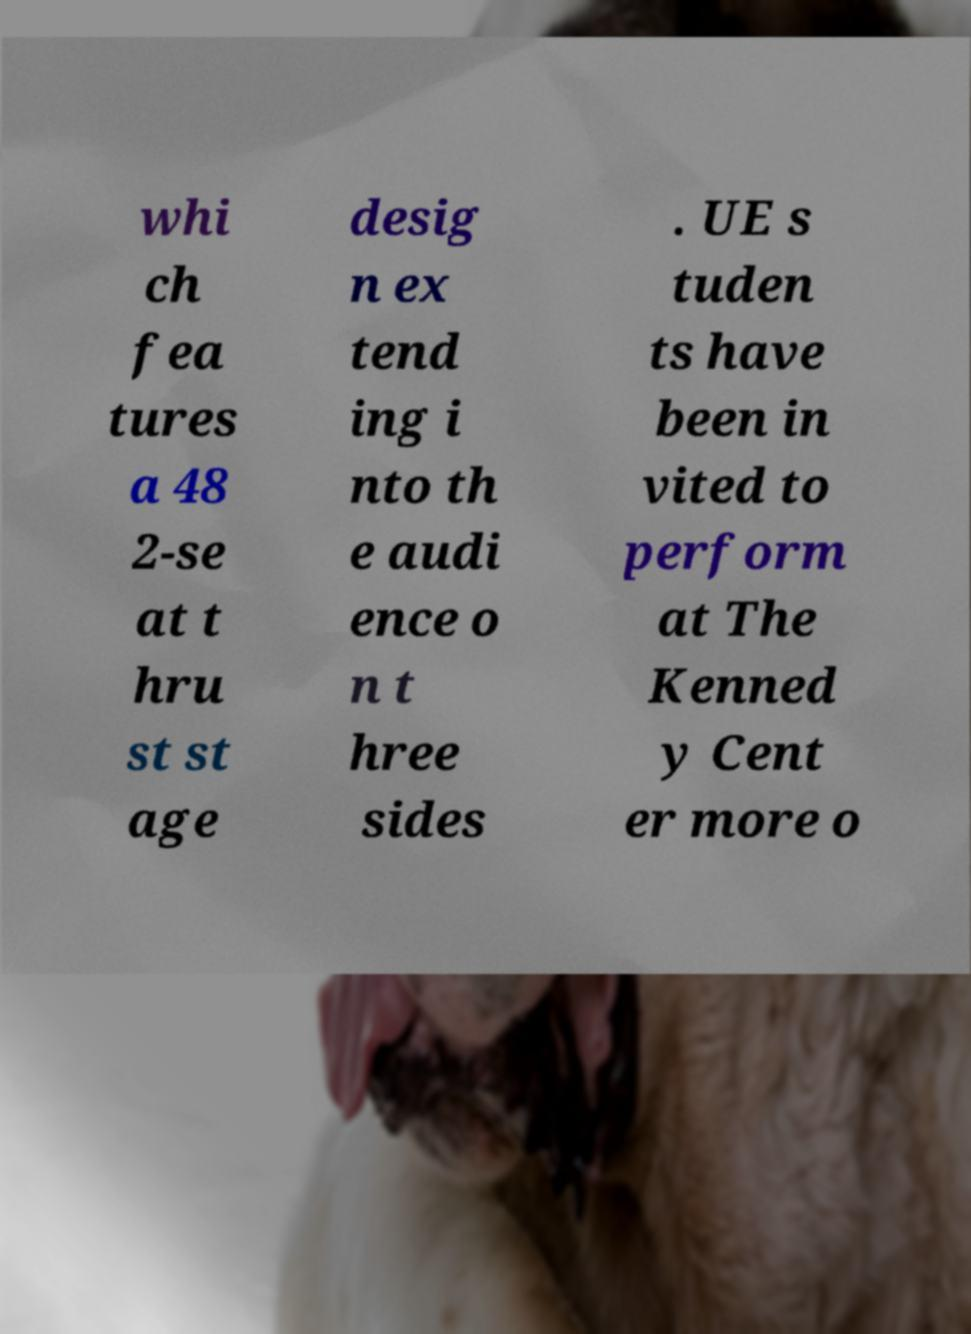Please read and relay the text visible in this image. What does it say? whi ch fea tures a 48 2-se at t hru st st age desig n ex tend ing i nto th e audi ence o n t hree sides . UE s tuden ts have been in vited to perform at The Kenned y Cent er more o 